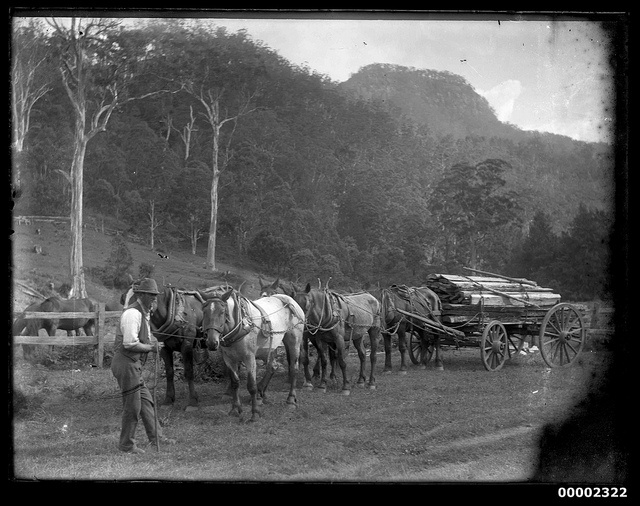Describe the objects in this image and their specific colors. I can see horse in black, gray, darkgray, and lightgray tones, people in black, gray, lightgray, and darkgray tones, horse in black, gray, darkgray, and lightgray tones, horse in black, gray, darkgray, and lightgray tones, and horse in black, gray, and lightgray tones in this image. 